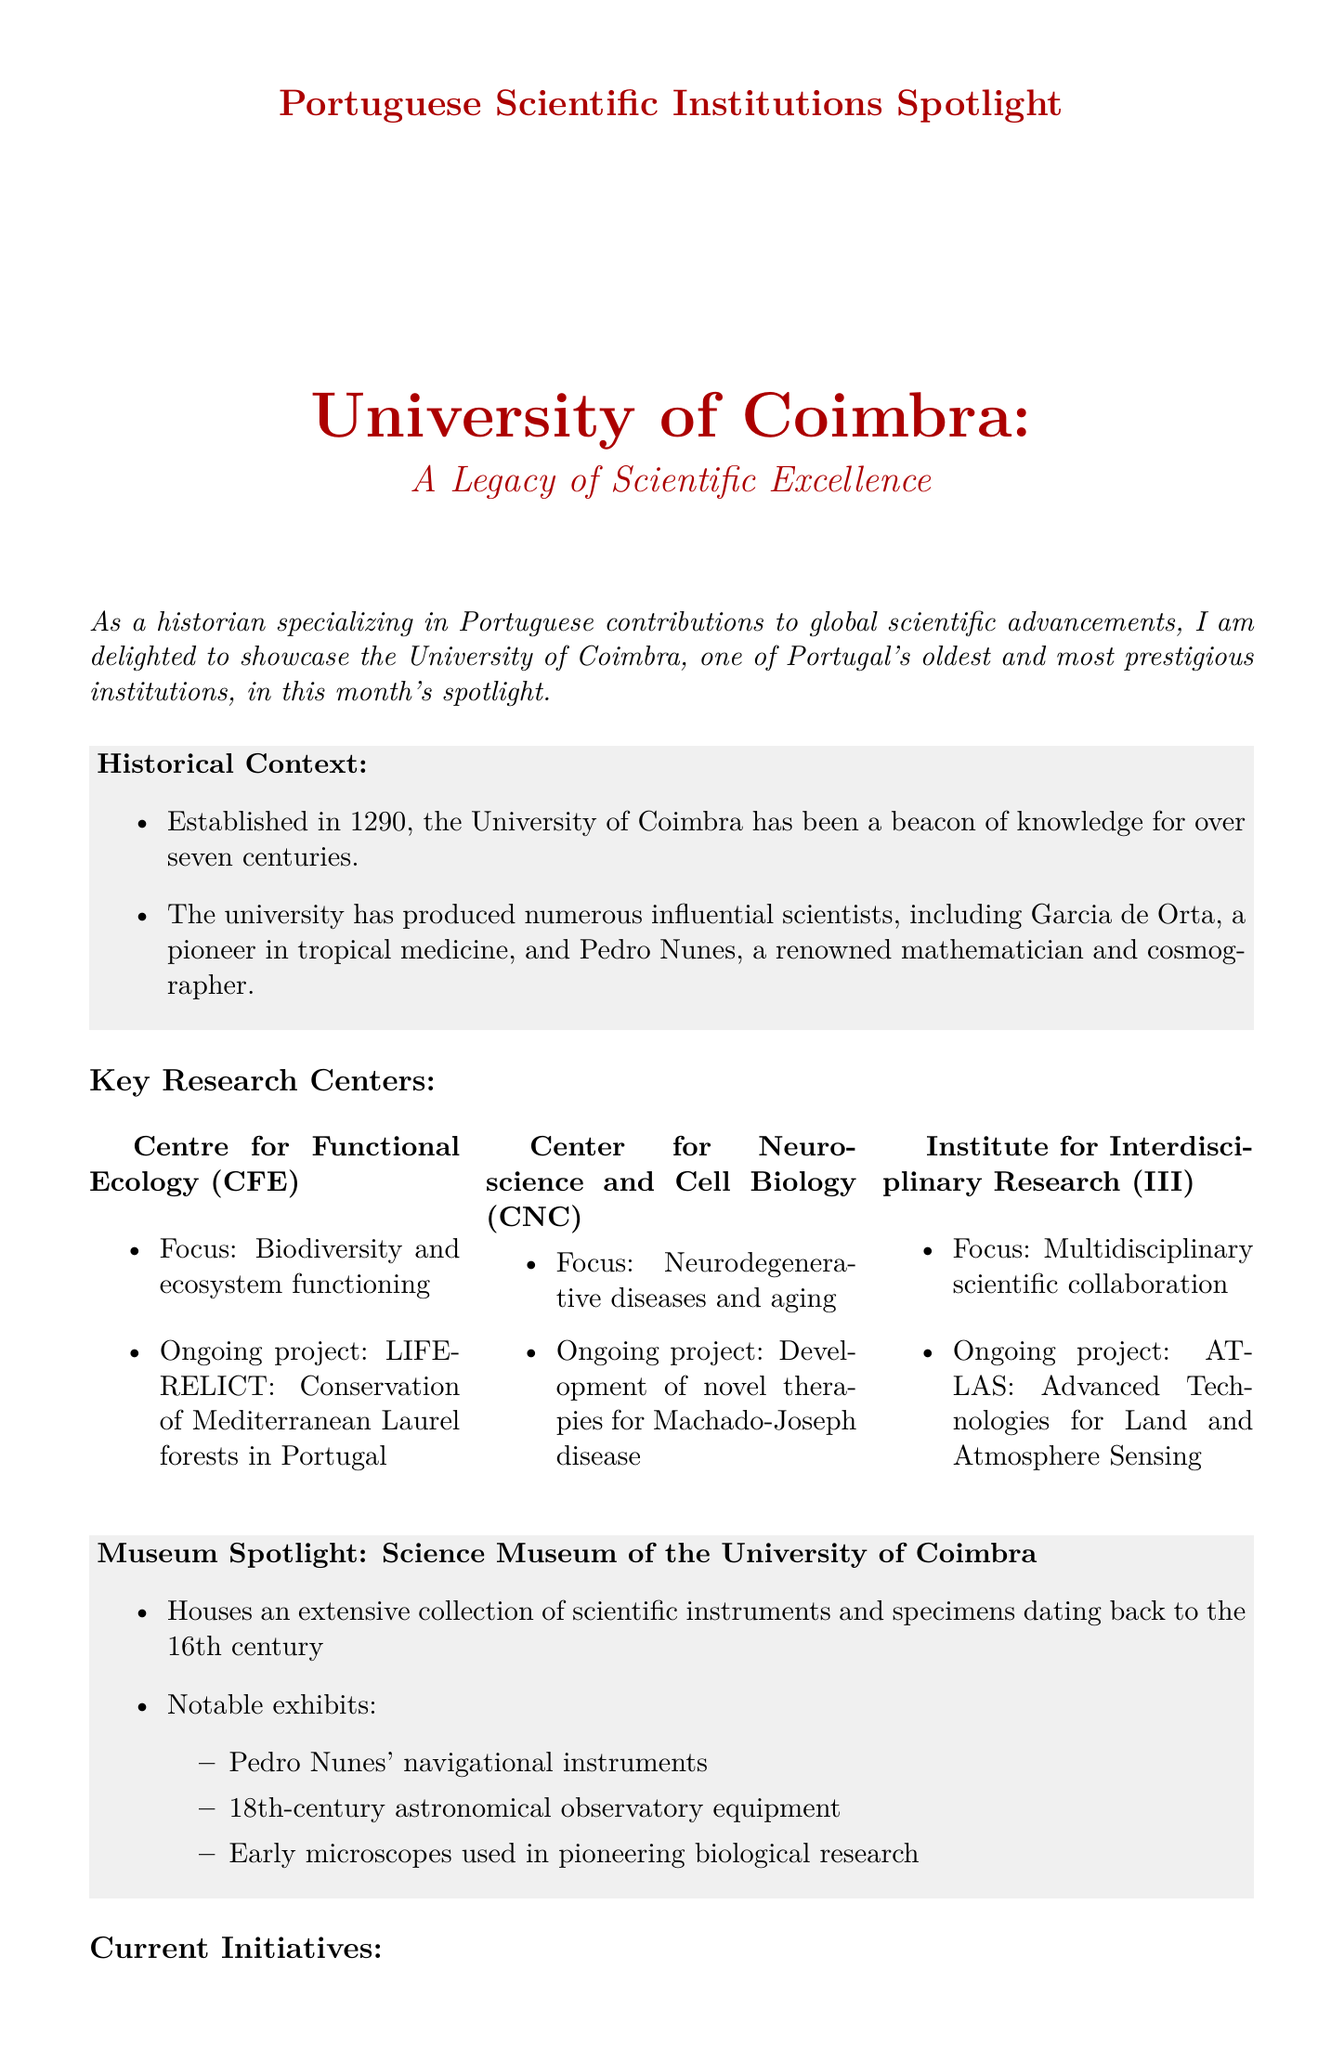What year was the University of Coimbra established? The founding year is specified in the historical context section of the document.
Answer: 1290 Who is a notable alumnus known for tropical medicine? The document mentions influential scientists as part of its historical context.
Answer: Garcia de Orta What is the focus of the Centre for Functional Ecology? The focus area for this research center is provided in the key research centers section.
Answer: Biodiversity and ecosystem functioning What ongoing project is associated with the Center for Neuroscience and Cell Biology? The ongoing project is mentioned in the description of the Center for Neuroscience and Cell Biology.
Answer: Development of novel therapies for Machado-Joseph disease What type of collection does the Science Museum of the University of Coimbra house? The description of the museum details the type of collection it has.
Answer: Scientific instruments and specimens Which project aims at sustainable plant-based food production? The document lists current initiatives along with their descriptions.
Answer: UC-InProPlant Who is the director of the Centre for Functional Ecology? The interview section specifies who the interviewee is and their title.
Answer: Dr. Maria João Feio Which initiative continues the tradition of Portuguese universities as hubs of global scientific exchange? The relevance of the UNITE! project is discussed in the current initiatives section.
Answer: UNITE! 